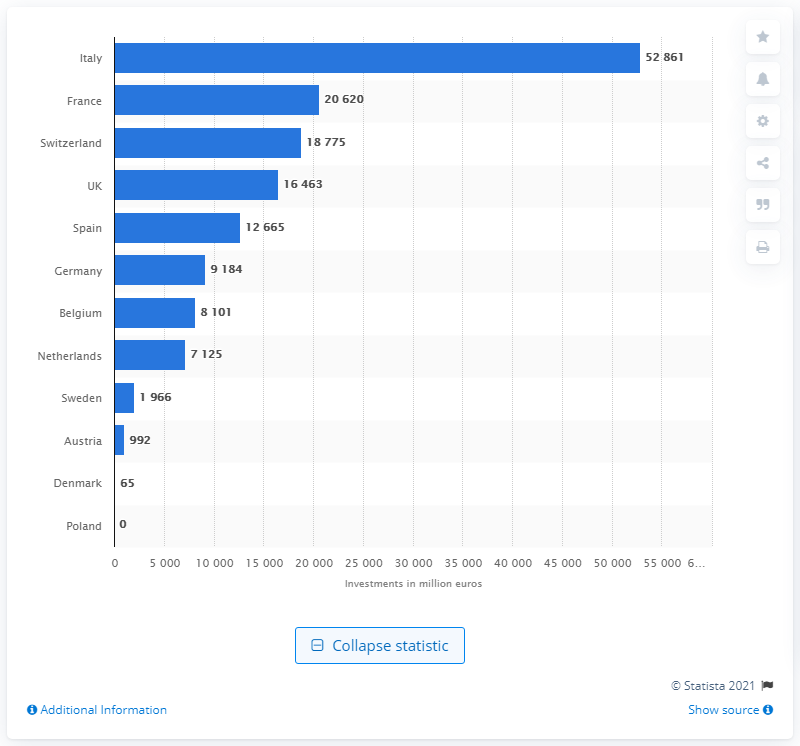Indicate a few pertinent items in this graphic. In 2017, Italy was the largest market for sustainability-themed SRI investments. In 2017, a total of 52,861 euros was invested in SRI in Italy. 